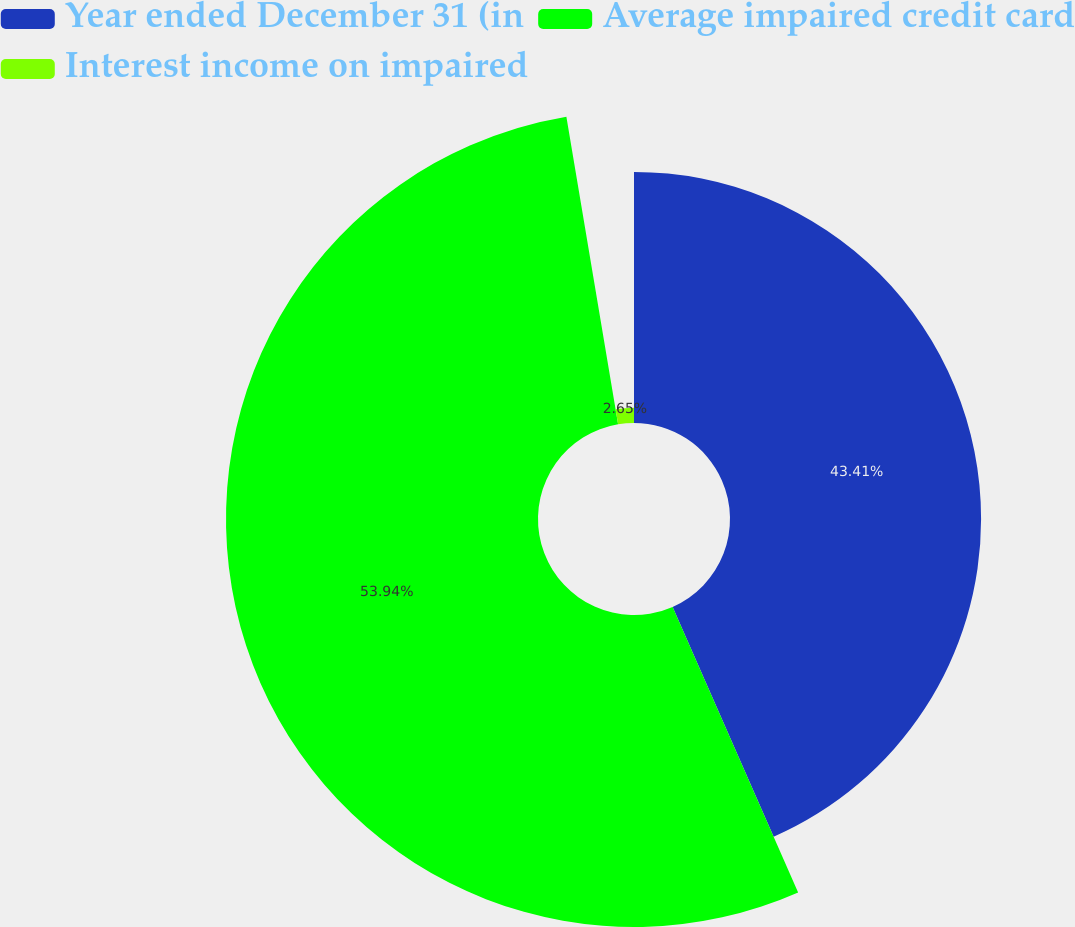Convert chart to OTSL. <chart><loc_0><loc_0><loc_500><loc_500><pie_chart><fcel>Year ended December 31 (in<fcel>Average impaired credit card<fcel>Interest income on impaired<nl><fcel>43.41%<fcel>53.94%<fcel>2.65%<nl></chart> 